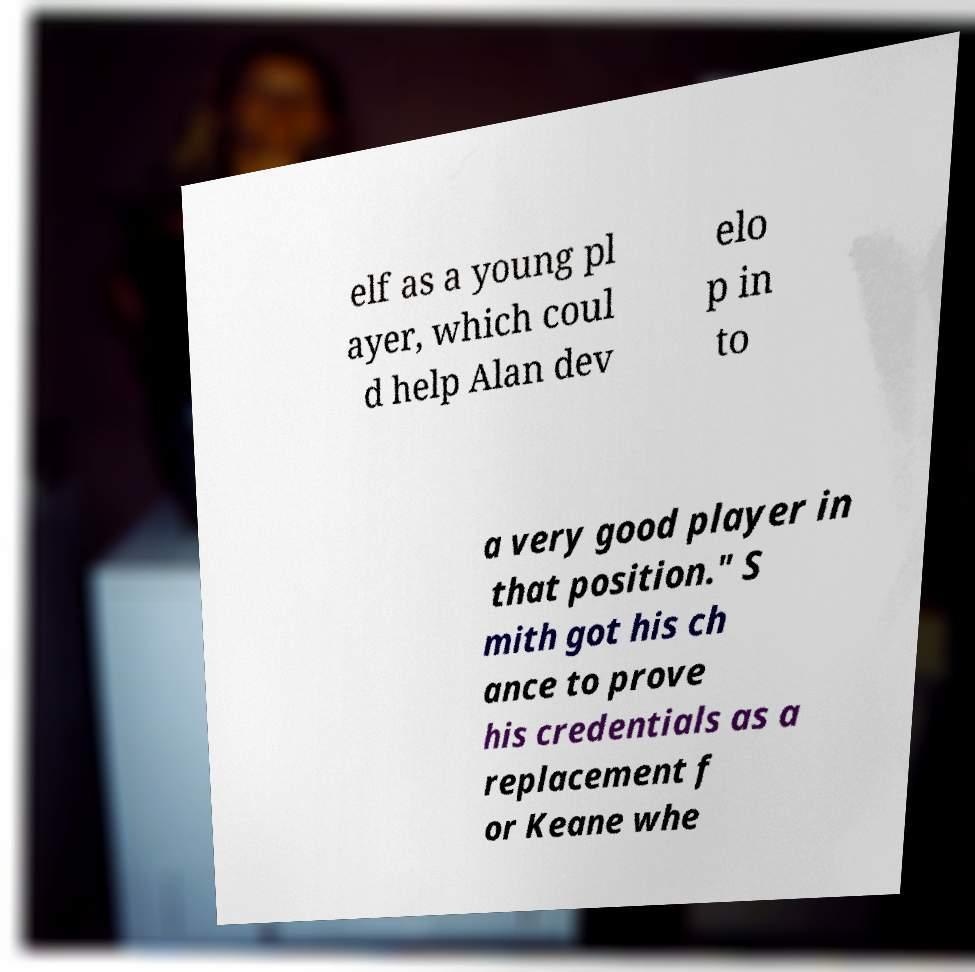Could you assist in decoding the text presented in this image and type it out clearly? elf as a young pl ayer, which coul d help Alan dev elo p in to a very good player in that position." S mith got his ch ance to prove his credentials as a replacement f or Keane whe 